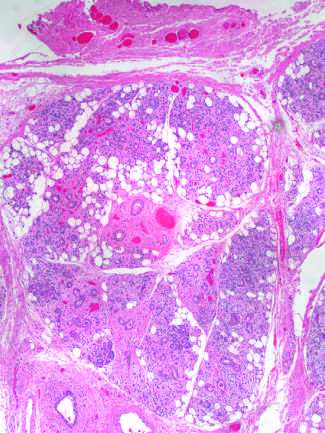s vascular changes and fibrosis of salivary glands produced by radiation therapy of the neck region?
Answer the question using a single word or phrase. Yes 